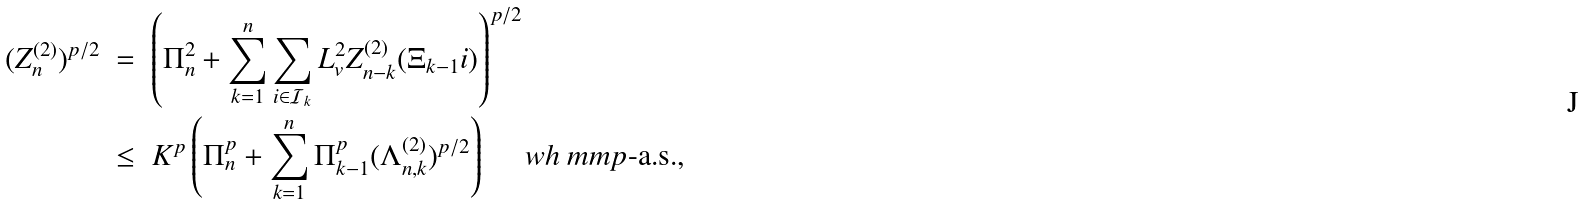<formula> <loc_0><loc_0><loc_500><loc_500>( Z _ { n } ^ { ( 2 ) } ) ^ { p / 2 } \ & = \ \left ( \Pi _ { n } ^ { 2 } + \sum _ { k = 1 } ^ { n } \sum _ { i \in \mathcal { I } _ { k } } L _ { v } ^ { 2 } Z _ { n - k } ^ { ( 2 ) } ( \Xi _ { k - 1 } i ) \right ) ^ { p / 2 } \\ & \leq \ K ^ { p } \left ( \Pi _ { n } ^ { p } + \sum _ { k = 1 } ^ { n } \Pi _ { k - 1 } ^ { p } ( \Lambda _ { n , k } ^ { ( 2 ) } ) ^ { p / 2 } \right ) \quad \ w h \ m m p \text {-a.s.} ,</formula> 